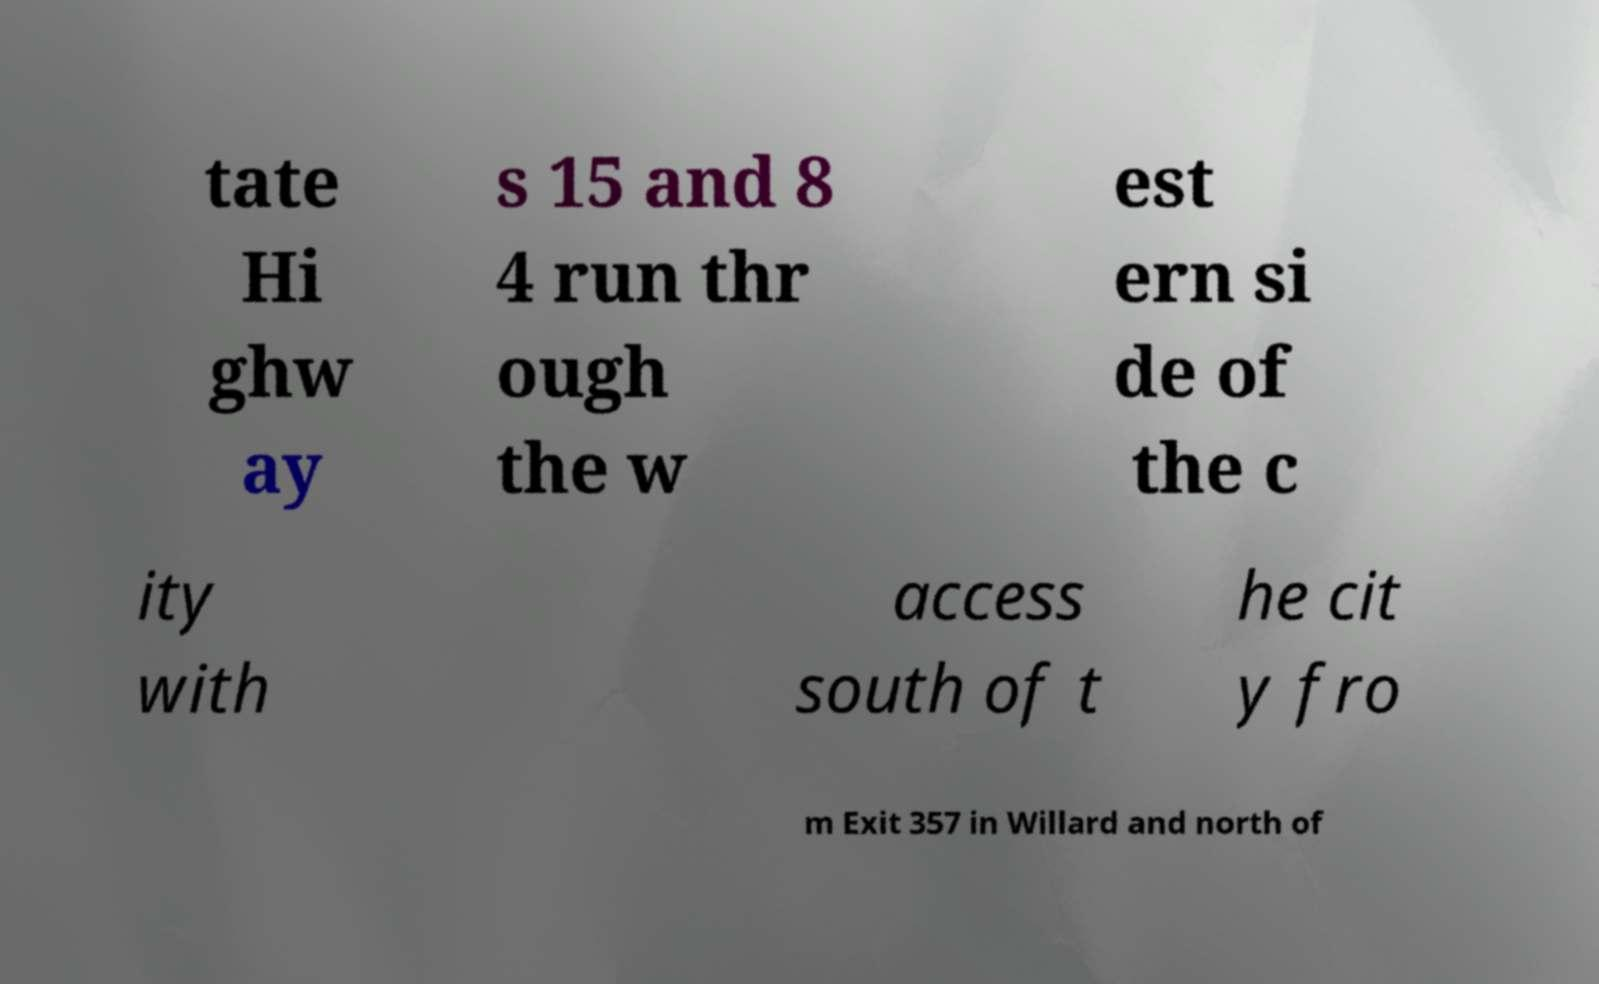Could you extract and type out the text from this image? tate Hi ghw ay s 15 and 8 4 run thr ough the w est ern si de of the c ity with access south of t he cit y fro m Exit 357 in Willard and north of 